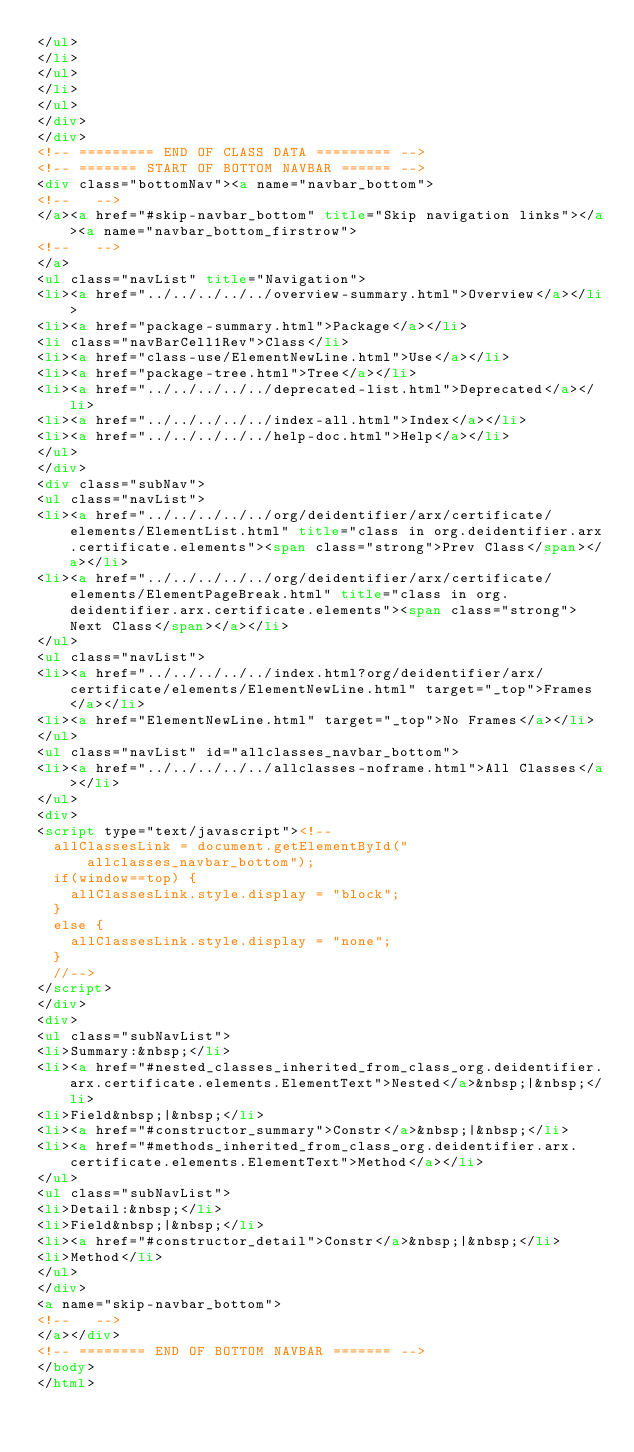<code> <loc_0><loc_0><loc_500><loc_500><_HTML_></ul>
</li>
</ul>
</li>
</ul>
</div>
</div>
<!-- ========= END OF CLASS DATA ========= -->
<!-- ======= START OF BOTTOM NAVBAR ====== -->
<div class="bottomNav"><a name="navbar_bottom">
<!--   -->
</a><a href="#skip-navbar_bottom" title="Skip navigation links"></a><a name="navbar_bottom_firstrow">
<!--   -->
</a>
<ul class="navList" title="Navigation">
<li><a href="../../../../../overview-summary.html">Overview</a></li>
<li><a href="package-summary.html">Package</a></li>
<li class="navBarCell1Rev">Class</li>
<li><a href="class-use/ElementNewLine.html">Use</a></li>
<li><a href="package-tree.html">Tree</a></li>
<li><a href="../../../../../deprecated-list.html">Deprecated</a></li>
<li><a href="../../../../../index-all.html">Index</a></li>
<li><a href="../../../../../help-doc.html">Help</a></li>
</ul>
</div>
<div class="subNav">
<ul class="navList">
<li><a href="../../../../../org/deidentifier/arx/certificate/elements/ElementList.html" title="class in org.deidentifier.arx.certificate.elements"><span class="strong">Prev Class</span></a></li>
<li><a href="../../../../../org/deidentifier/arx/certificate/elements/ElementPageBreak.html" title="class in org.deidentifier.arx.certificate.elements"><span class="strong">Next Class</span></a></li>
</ul>
<ul class="navList">
<li><a href="../../../../../index.html?org/deidentifier/arx/certificate/elements/ElementNewLine.html" target="_top">Frames</a></li>
<li><a href="ElementNewLine.html" target="_top">No Frames</a></li>
</ul>
<ul class="navList" id="allclasses_navbar_bottom">
<li><a href="../../../../../allclasses-noframe.html">All Classes</a></li>
</ul>
<div>
<script type="text/javascript"><!--
  allClassesLink = document.getElementById("allclasses_navbar_bottom");
  if(window==top) {
    allClassesLink.style.display = "block";
  }
  else {
    allClassesLink.style.display = "none";
  }
  //-->
</script>
</div>
<div>
<ul class="subNavList">
<li>Summary:&nbsp;</li>
<li><a href="#nested_classes_inherited_from_class_org.deidentifier.arx.certificate.elements.ElementText">Nested</a>&nbsp;|&nbsp;</li>
<li>Field&nbsp;|&nbsp;</li>
<li><a href="#constructor_summary">Constr</a>&nbsp;|&nbsp;</li>
<li><a href="#methods_inherited_from_class_org.deidentifier.arx.certificate.elements.ElementText">Method</a></li>
</ul>
<ul class="subNavList">
<li>Detail:&nbsp;</li>
<li>Field&nbsp;|&nbsp;</li>
<li><a href="#constructor_detail">Constr</a>&nbsp;|&nbsp;</li>
<li>Method</li>
</ul>
</div>
<a name="skip-navbar_bottom">
<!--   -->
</a></div>
<!-- ======== END OF BOTTOM NAVBAR ======= -->
</body>
</html>
</code> 